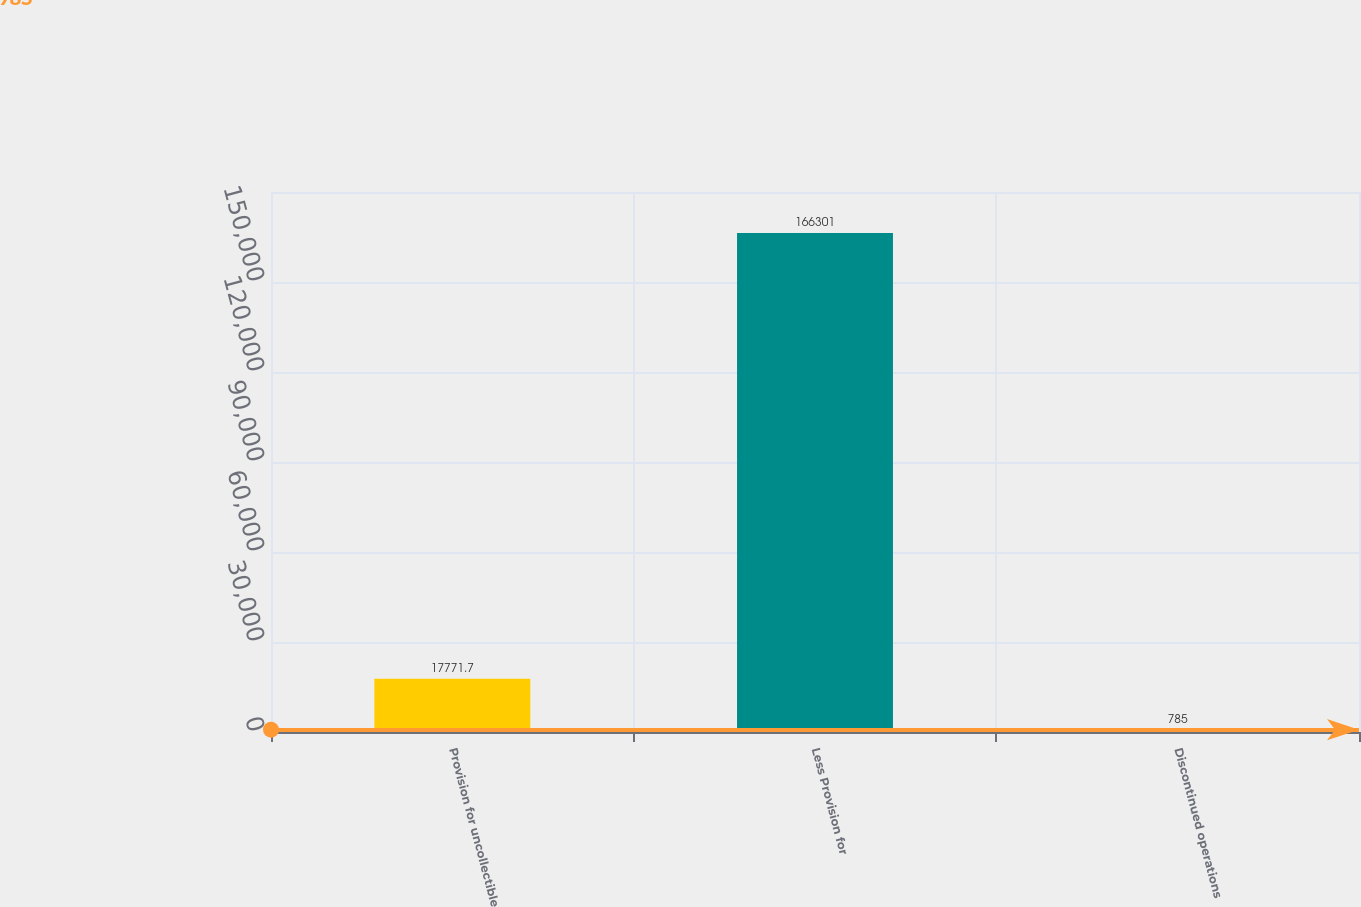<chart> <loc_0><loc_0><loc_500><loc_500><bar_chart><fcel>Provision for uncollectible<fcel>Less Provision for<fcel>Discontinued operations<nl><fcel>17771.7<fcel>166301<fcel>785<nl></chart> 